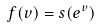<formula> <loc_0><loc_0><loc_500><loc_500>f ( v ) = s ( e ^ { v } )</formula> 